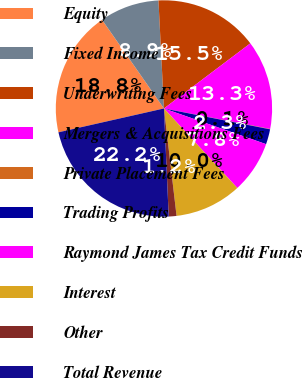Convert chart to OTSL. <chart><loc_0><loc_0><loc_500><loc_500><pie_chart><fcel>Equity<fcel>Fixed Income<fcel>Underwriting Fees<fcel>Mergers & Acquisitions Fees<fcel>Private Placement Fees<fcel>Trading Profits<fcel>Raymond James Tax Credit Funds<fcel>Interest<fcel>Other<fcel>Total Revenue<nl><fcel>18.84%<fcel>8.89%<fcel>15.53%<fcel>13.32%<fcel>0.05%<fcel>2.26%<fcel>7.79%<fcel>10.0%<fcel>1.16%<fcel>22.16%<nl></chart> 